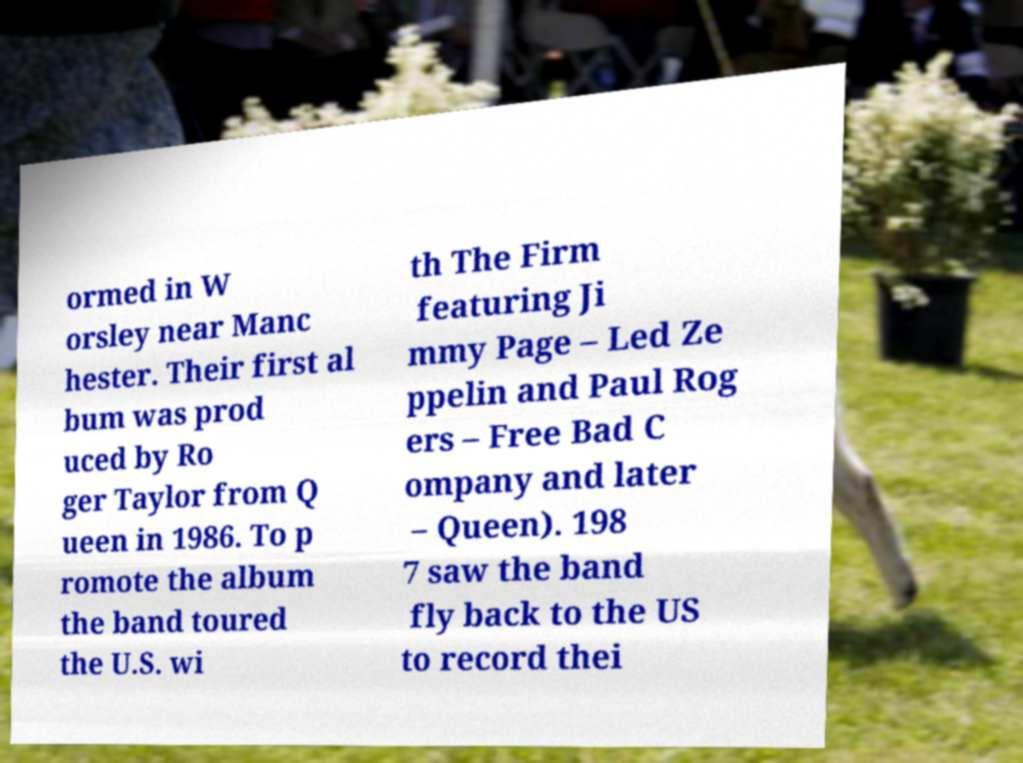Could you extract and type out the text from this image? ormed in W orsley near Manc hester. Their first al bum was prod uced by Ro ger Taylor from Q ueen in 1986. To p romote the album the band toured the U.S. wi th The Firm featuring Ji mmy Page – Led Ze ppelin and Paul Rog ers – Free Bad C ompany and later – Queen). 198 7 saw the band fly back to the US to record thei 